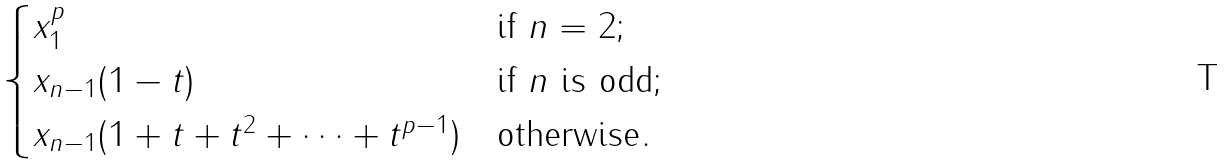Convert formula to latex. <formula><loc_0><loc_0><loc_500><loc_500>\begin{cases} x _ { 1 } ^ { p } & \text {if } n = 2 ; \\ x _ { n - 1 } ( 1 - t ) & \text {if } n \text { is odd} ; \\ x _ { n - 1 } ( 1 + t + t ^ { 2 } + \cdots + t ^ { p - 1 } ) & \text {otherwise} . \end{cases}</formula> 